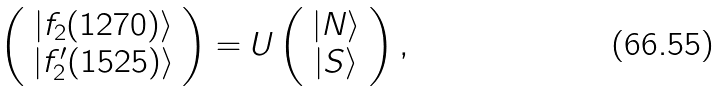<formula> <loc_0><loc_0><loc_500><loc_500>\left ( \begin{array} { c } { { | f _ { 2 } ( 1 2 7 0 ) \rangle } } \\ { { | f _ { 2 } ^ { \prime } ( 1 5 2 5 ) \rangle } } \end{array} \right ) = U \left ( \begin{array} { c } { | N \rangle } \\ { | S \rangle } \end{array} \right ) ,</formula> 